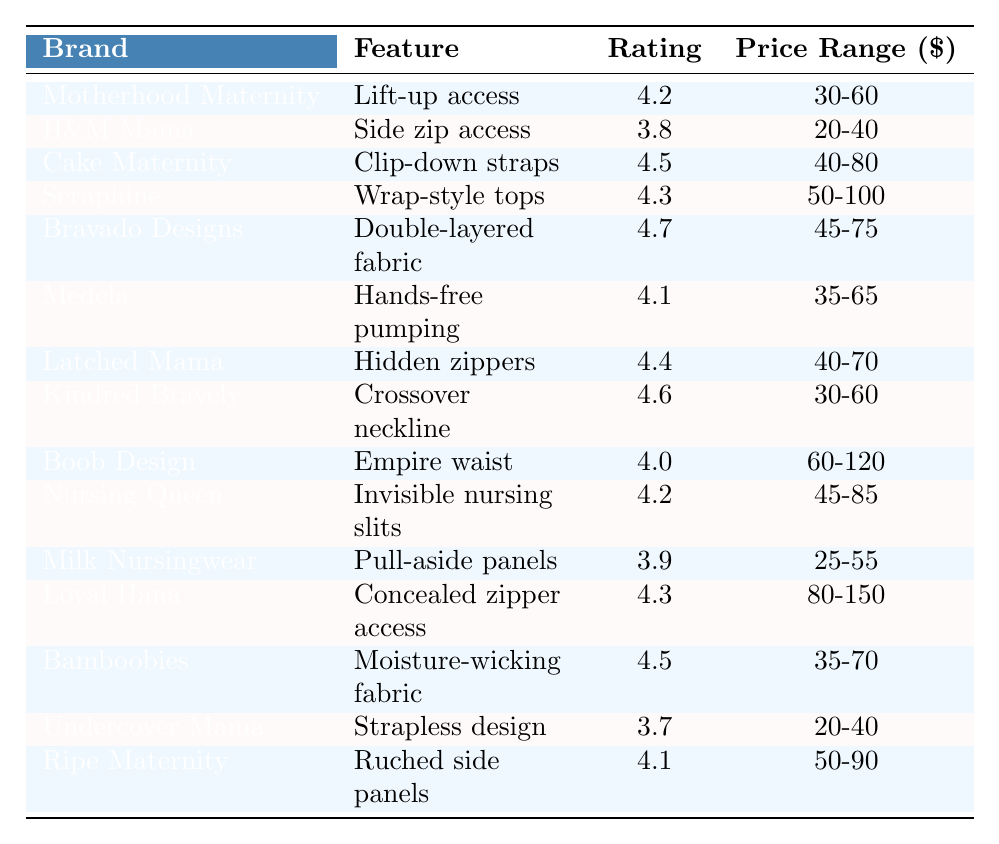What is the customer rating for Bravado Designs? The table shows that Bravado Designs has a customer rating of 4.7.
Answer: 4.7 Which clothing brand has the lowest customer rating? By examining the ratings in the table, Undercover Mama has the lowest rating of 3.7.
Answer: Undercover Mama What is the price range for Cake Maternity? The table indicates that Cake Maternity has a price range of $40-80.
Answer: $40-80 How many brands have a customer rating of 4.5 or higher? The brands with ratings of 4.5 or higher are Cake Maternity, Bravado Designs, Kindred Bravely, and Bamboobies, totaling 4 brands.
Answer: 4 What is the average customer rating of all listed brands? The ratings are 4.2, 3.8, 4.5, 4.3, 4.7, 4.1, 4.4, 4.6, 4.0, 4.2, 3.9, 4.3, 4.5, 3.7, 4.1. Summing these gives 65.2, and dividing by 15 (the number of brands) yields an average of approximately 4.35.
Answer: 4.35 Is the price range for Nursing Queen greater than $60? The price range for Nursing Queen is $45-85, which is indeed greater than $60.
Answer: Yes What feature does Kindred Bravely offer? According to the table, Kindred Bravely offers a crossover neckline feature.
Answer: Crossover neckline Which brand offers hands-free pumping and what is its rating? The brand that offers hands-free pumping is Medela, with a customer rating of 4.1.
Answer: Medela, 4.1 What is the difference in customer rating between Bravado Designs and Milk Nursingwear? Bravado Designs has a rating of 4.7, and Milk Nursingwear has a rating of 3.9. The difference is 4.7 - 3.9 = 0.8.
Answer: 0.8 How many brands feature hidden access options (like zippers)? The brands that feature hidden access options are H&M Mama (side zip), Latched Mama (hidden zippers), and Loyal Hana (concealed zipper). Thus, there are 3 brands.
Answer: 3 What percentage of the brands listed have a rating of 4.0 or higher? Out of 15 brands, 11 have ratings of 4.0 or higher. Therefore, the percentage is (11/15) * 100 = 73.33%.
Answer: 73.33% 